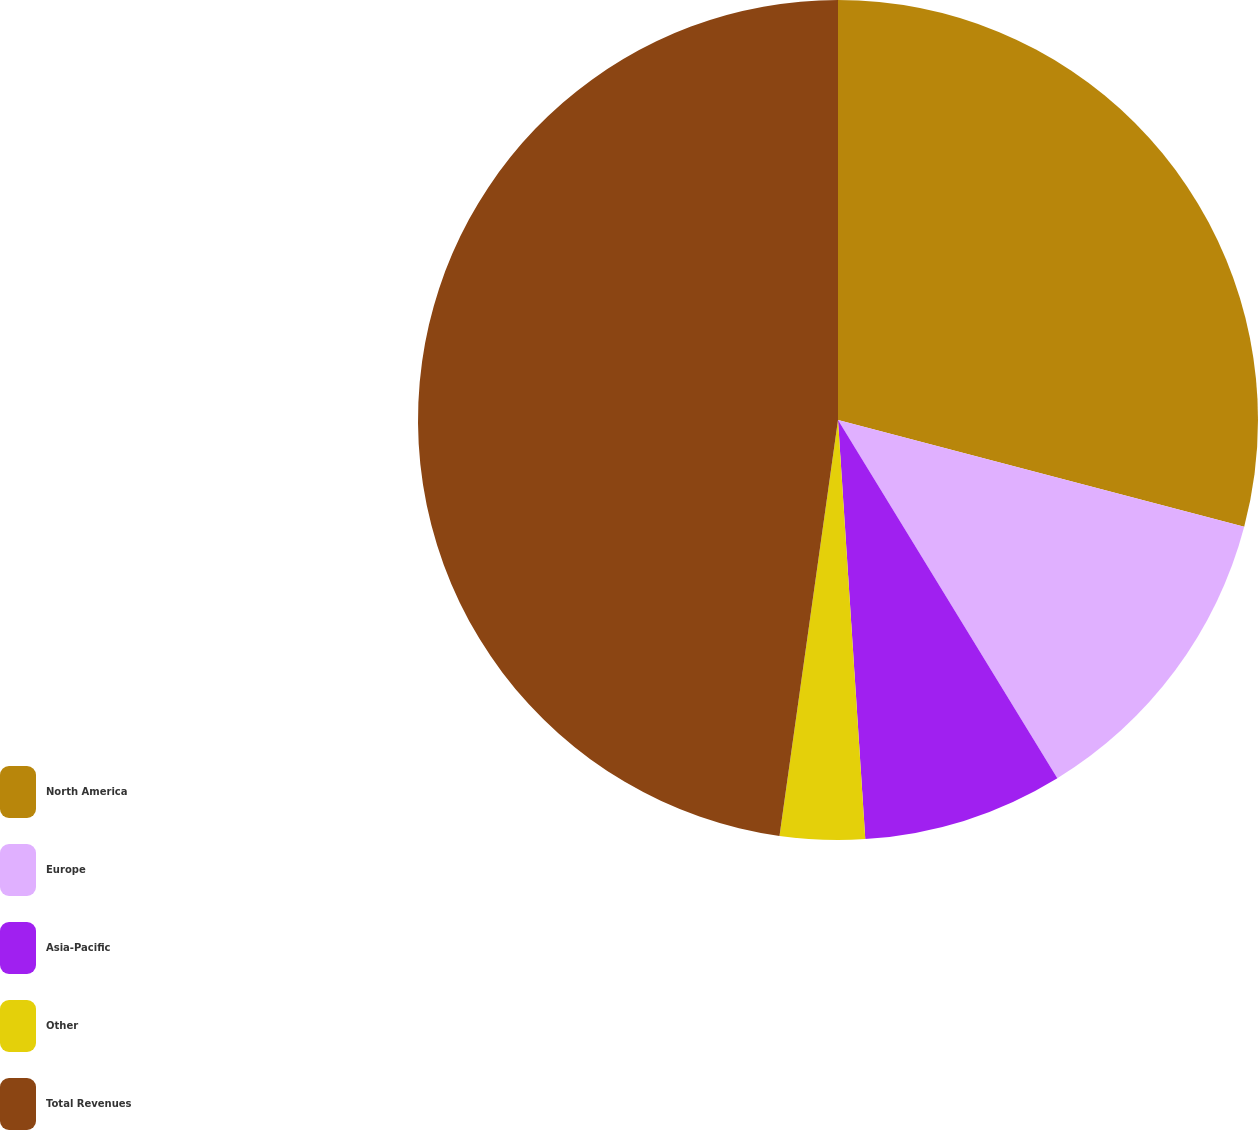<chart> <loc_0><loc_0><loc_500><loc_500><pie_chart><fcel>North America<fcel>Europe<fcel>Asia-Pacific<fcel>Other<fcel>Total Revenues<nl><fcel>29.09%<fcel>12.16%<fcel>7.71%<fcel>3.26%<fcel>47.77%<nl></chart> 